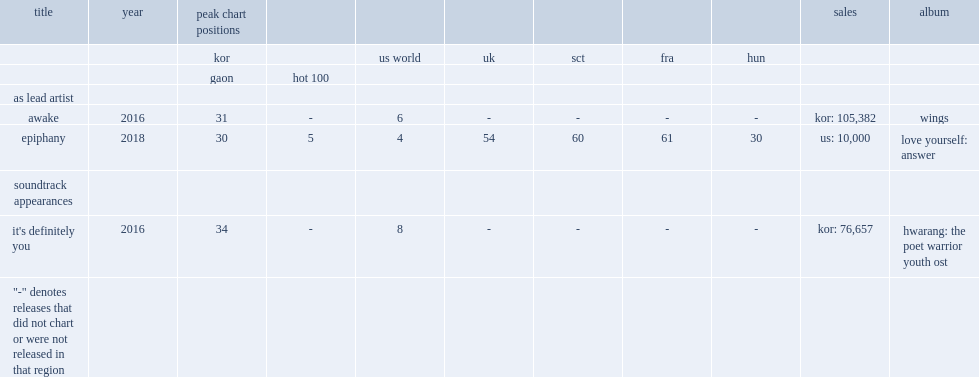When did the single "epiphany" release? 2018.0. 